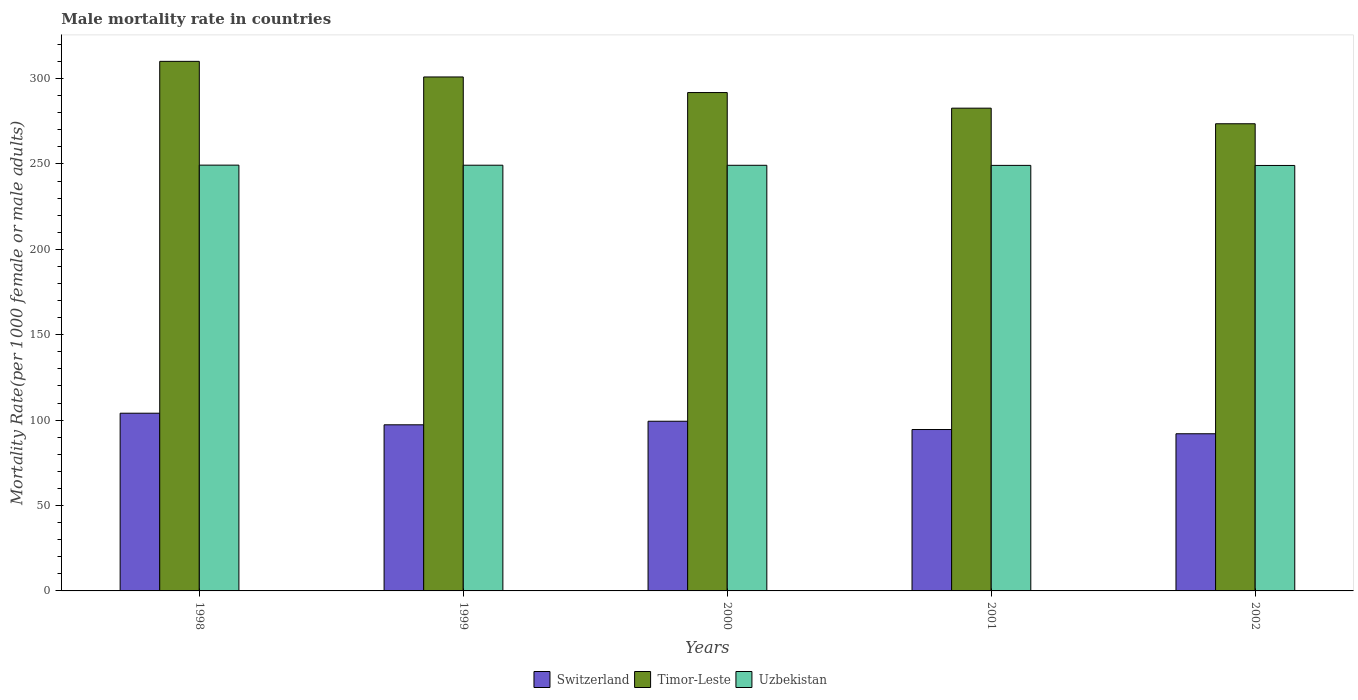How many different coloured bars are there?
Provide a short and direct response. 3. How many groups of bars are there?
Give a very brief answer. 5. How many bars are there on the 3rd tick from the left?
Your answer should be compact. 3. What is the label of the 1st group of bars from the left?
Your answer should be very brief. 1998. In how many cases, is the number of bars for a given year not equal to the number of legend labels?
Provide a succinct answer. 0. What is the male mortality rate in Switzerland in 2002?
Your response must be concise. 92.02. Across all years, what is the maximum male mortality rate in Uzbekistan?
Provide a short and direct response. 249.32. Across all years, what is the minimum male mortality rate in Uzbekistan?
Give a very brief answer. 249.12. In which year was the male mortality rate in Timor-Leste maximum?
Provide a succinct answer. 1998. What is the total male mortality rate in Uzbekistan in the graph?
Provide a short and direct response. 1246.09. What is the difference between the male mortality rate in Uzbekistan in 1999 and that in 2001?
Provide a succinct answer. 0.1. What is the difference between the male mortality rate in Timor-Leste in 2000 and the male mortality rate in Switzerland in 1998?
Give a very brief answer. 187.76. What is the average male mortality rate in Uzbekistan per year?
Provide a short and direct response. 249.22. In the year 1999, what is the difference between the male mortality rate in Switzerland and male mortality rate in Timor-Leste?
Make the answer very short. -203.68. What is the ratio of the male mortality rate in Timor-Leste in 1998 to that in 1999?
Give a very brief answer. 1.03. Is the male mortality rate in Timor-Leste in 1998 less than that in 1999?
Offer a terse response. No. What is the difference between the highest and the second highest male mortality rate in Uzbekistan?
Your response must be concise. 0.05. What is the difference between the highest and the lowest male mortality rate in Timor-Leste?
Provide a succinct answer. 36.54. In how many years, is the male mortality rate in Uzbekistan greater than the average male mortality rate in Uzbekistan taken over all years?
Provide a short and direct response. 2. Is the sum of the male mortality rate in Switzerland in 2001 and 2002 greater than the maximum male mortality rate in Timor-Leste across all years?
Your answer should be compact. No. What does the 3rd bar from the left in 2002 represents?
Provide a succinct answer. Uzbekistan. What does the 3rd bar from the right in 2000 represents?
Ensure brevity in your answer.  Switzerland. How many bars are there?
Provide a succinct answer. 15. Are all the bars in the graph horizontal?
Offer a very short reply. No. How many years are there in the graph?
Your answer should be compact. 5. What is the difference between two consecutive major ticks on the Y-axis?
Give a very brief answer. 50. Are the values on the major ticks of Y-axis written in scientific E-notation?
Offer a very short reply. No. Does the graph contain any zero values?
Provide a succinct answer. No. How many legend labels are there?
Offer a terse response. 3. How are the legend labels stacked?
Ensure brevity in your answer.  Horizontal. What is the title of the graph?
Your answer should be compact. Male mortality rate in countries. Does "Europe(all income levels)" appear as one of the legend labels in the graph?
Ensure brevity in your answer.  No. What is the label or title of the Y-axis?
Provide a succinct answer. Mortality Rate(per 1000 female or male adults). What is the Mortality Rate(per 1000 female or male adults) of Switzerland in 1998?
Provide a succinct answer. 104.05. What is the Mortality Rate(per 1000 female or male adults) in Timor-Leste in 1998?
Your answer should be very brief. 310.08. What is the Mortality Rate(per 1000 female or male adults) in Uzbekistan in 1998?
Give a very brief answer. 249.32. What is the Mortality Rate(per 1000 female or male adults) of Switzerland in 1999?
Provide a short and direct response. 97.26. What is the Mortality Rate(per 1000 female or male adults) of Timor-Leste in 1999?
Keep it short and to the point. 300.94. What is the Mortality Rate(per 1000 female or male adults) of Uzbekistan in 1999?
Ensure brevity in your answer.  249.27. What is the Mortality Rate(per 1000 female or male adults) in Switzerland in 2000?
Offer a terse response. 99.35. What is the Mortality Rate(per 1000 female or male adults) in Timor-Leste in 2000?
Give a very brief answer. 291.81. What is the Mortality Rate(per 1000 female or male adults) in Uzbekistan in 2000?
Offer a terse response. 249.22. What is the Mortality Rate(per 1000 female or male adults) in Switzerland in 2001?
Ensure brevity in your answer.  94.51. What is the Mortality Rate(per 1000 female or male adults) of Timor-Leste in 2001?
Your answer should be compact. 282.67. What is the Mortality Rate(per 1000 female or male adults) of Uzbekistan in 2001?
Your answer should be very brief. 249.17. What is the Mortality Rate(per 1000 female or male adults) in Switzerland in 2002?
Offer a very short reply. 92.02. What is the Mortality Rate(per 1000 female or male adults) of Timor-Leste in 2002?
Provide a short and direct response. 273.54. What is the Mortality Rate(per 1000 female or male adults) in Uzbekistan in 2002?
Provide a short and direct response. 249.12. Across all years, what is the maximum Mortality Rate(per 1000 female or male adults) in Switzerland?
Your answer should be compact. 104.05. Across all years, what is the maximum Mortality Rate(per 1000 female or male adults) in Timor-Leste?
Make the answer very short. 310.08. Across all years, what is the maximum Mortality Rate(per 1000 female or male adults) of Uzbekistan?
Offer a very short reply. 249.32. Across all years, what is the minimum Mortality Rate(per 1000 female or male adults) of Switzerland?
Make the answer very short. 92.02. Across all years, what is the minimum Mortality Rate(per 1000 female or male adults) of Timor-Leste?
Your answer should be very brief. 273.54. Across all years, what is the minimum Mortality Rate(per 1000 female or male adults) of Uzbekistan?
Your answer should be compact. 249.12. What is the total Mortality Rate(per 1000 female or male adults) in Switzerland in the graph?
Give a very brief answer. 487.19. What is the total Mortality Rate(per 1000 female or male adults) in Timor-Leste in the graph?
Offer a terse response. 1459.04. What is the total Mortality Rate(per 1000 female or male adults) in Uzbekistan in the graph?
Your response must be concise. 1246.09. What is the difference between the Mortality Rate(per 1000 female or male adults) of Switzerland in 1998 and that in 1999?
Provide a succinct answer. 6.79. What is the difference between the Mortality Rate(per 1000 female or male adults) of Timor-Leste in 1998 and that in 1999?
Ensure brevity in your answer.  9.14. What is the difference between the Mortality Rate(per 1000 female or male adults) in Uzbekistan in 1998 and that in 1999?
Ensure brevity in your answer.  0.05. What is the difference between the Mortality Rate(per 1000 female or male adults) in Switzerland in 1998 and that in 2000?
Offer a very short reply. 4.7. What is the difference between the Mortality Rate(per 1000 female or male adults) in Timor-Leste in 1998 and that in 2000?
Provide a succinct answer. 18.27. What is the difference between the Mortality Rate(per 1000 female or male adults) in Uzbekistan in 1998 and that in 2000?
Your answer should be very brief. 0.1. What is the difference between the Mortality Rate(per 1000 female or male adults) in Switzerland in 1998 and that in 2001?
Your answer should be compact. 9.54. What is the difference between the Mortality Rate(per 1000 female or male adults) of Timor-Leste in 1998 and that in 2001?
Give a very brief answer. 27.41. What is the difference between the Mortality Rate(per 1000 female or male adults) of Uzbekistan in 1998 and that in 2001?
Provide a short and direct response. 0.15. What is the difference between the Mortality Rate(per 1000 female or male adults) of Switzerland in 1998 and that in 2002?
Give a very brief answer. 12.03. What is the difference between the Mortality Rate(per 1000 female or male adults) of Timor-Leste in 1998 and that in 2002?
Offer a very short reply. 36.54. What is the difference between the Mortality Rate(per 1000 female or male adults) of Uzbekistan in 1998 and that in 2002?
Your response must be concise. 0.2. What is the difference between the Mortality Rate(per 1000 female or male adults) in Switzerland in 1999 and that in 2000?
Make the answer very short. -2.09. What is the difference between the Mortality Rate(per 1000 female or male adults) in Timor-Leste in 1999 and that in 2000?
Your answer should be compact. 9.14. What is the difference between the Mortality Rate(per 1000 female or male adults) in Uzbekistan in 1999 and that in 2000?
Your answer should be very brief. 0.05. What is the difference between the Mortality Rate(per 1000 female or male adults) in Switzerland in 1999 and that in 2001?
Offer a very short reply. 2.75. What is the difference between the Mortality Rate(per 1000 female or male adults) of Timor-Leste in 1999 and that in 2001?
Provide a short and direct response. 18.27. What is the difference between the Mortality Rate(per 1000 female or male adults) of Uzbekistan in 1999 and that in 2001?
Offer a terse response. 0.1. What is the difference between the Mortality Rate(per 1000 female or male adults) of Switzerland in 1999 and that in 2002?
Your answer should be compact. 5.24. What is the difference between the Mortality Rate(per 1000 female or male adults) of Timor-Leste in 1999 and that in 2002?
Your answer should be very brief. 27.41. What is the difference between the Mortality Rate(per 1000 female or male adults) of Uzbekistan in 1999 and that in 2002?
Offer a terse response. 0.15. What is the difference between the Mortality Rate(per 1000 female or male adults) in Switzerland in 2000 and that in 2001?
Offer a very short reply. 4.84. What is the difference between the Mortality Rate(per 1000 female or male adults) of Timor-Leste in 2000 and that in 2001?
Your answer should be very brief. 9.14. What is the difference between the Mortality Rate(per 1000 female or male adults) in Uzbekistan in 2000 and that in 2001?
Ensure brevity in your answer.  0.05. What is the difference between the Mortality Rate(per 1000 female or male adults) in Switzerland in 2000 and that in 2002?
Your response must be concise. 7.33. What is the difference between the Mortality Rate(per 1000 female or male adults) of Timor-Leste in 2000 and that in 2002?
Make the answer very short. 18.27. What is the difference between the Mortality Rate(per 1000 female or male adults) in Uzbekistan in 2000 and that in 2002?
Make the answer very short. 0.1. What is the difference between the Mortality Rate(per 1000 female or male adults) of Switzerland in 2001 and that in 2002?
Your answer should be compact. 2.48. What is the difference between the Mortality Rate(per 1000 female or male adults) in Timor-Leste in 2001 and that in 2002?
Ensure brevity in your answer.  9.14. What is the difference between the Mortality Rate(per 1000 female or male adults) in Uzbekistan in 2001 and that in 2002?
Ensure brevity in your answer.  0.05. What is the difference between the Mortality Rate(per 1000 female or male adults) in Switzerland in 1998 and the Mortality Rate(per 1000 female or male adults) in Timor-Leste in 1999?
Offer a very short reply. -196.89. What is the difference between the Mortality Rate(per 1000 female or male adults) of Switzerland in 1998 and the Mortality Rate(per 1000 female or male adults) of Uzbekistan in 1999?
Keep it short and to the point. -145.22. What is the difference between the Mortality Rate(per 1000 female or male adults) of Timor-Leste in 1998 and the Mortality Rate(per 1000 female or male adults) of Uzbekistan in 1999?
Your answer should be very brief. 60.81. What is the difference between the Mortality Rate(per 1000 female or male adults) of Switzerland in 1998 and the Mortality Rate(per 1000 female or male adults) of Timor-Leste in 2000?
Provide a succinct answer. -187.76. What is the difference between the Mortality Rate(per 1000 female or male adults) in Switzerland in 1998 and the Mortality Rate(per 1000 female or male adults) in Uzbekistan in 2000?
Give a very brief answer. -145.17. What is the difference between the Mortality Rate(per 1000 female or male adults) of Timor-Leste in 1998 and the Mortality Rate(per 1000 female or male adults) of Uzbekistan in 2000?
Offer a terse response. 60.86. What is the difference between the Mortality Rate(per 1000 female or male adults) in Switzerland in 1998 and the Mortality Rate(per 1000 female or male adults) in Timor-Leste in 2001?
Offer a very short reply. -178.62. What is the difference between the Mortality Rate(per 1000 female or male adults) in Switzerland in 1998 and the Mortality Rate(per 1000 female or male adults) in Uzbekistan in 2001?
Offer a terse response. -145.12. What is the difference between the Mortality Rate(per 1000 female or male adults) in Timor-Leste in 1998 and the Mortality Rate(per 1000 female or male adults) in Uzbekistan in 2001?
Ensure brevity in your answer.  60.91. What is the difference between the Mortality Rate(per 1000 female or male adults) of Switzerland in 1998 and the Mortality Rate(per 1000 female or male adults) of Timor-Leste in 2002?
Make the answer very short. -169.49. What is the difference between the Mortality Rate(per 1000 female or male adults) of Switzerland in 1998 and the Mortality Rate(per 1000 female or male adults) of Uzbekistan in 2002?
Offer a very short reply. -145.07. What is the difference between the Mortality Rate(per 1000 female or male adults) in Timor-Leste in 1998 and the Mortality Rate(per 1000 female or male adults) in Uzbekistan in 2002?
Your answer should be very brief. 60.96. What is the difference between the Mortality Rate(per 1000 female or male adults) of Switzerland in 1999 and the Mortality Rate(per 1000 female or male adults) of Timor-Leste in 2000?
Ensure brevity in your answer.  -194.55. What is the difference between the Mortality Rate(per 1000 female or male adults) of Switzerland in 1999 and the Mortality Rate(per 1000 female or male adults) of Uzbekistan in 2000?
Your answer should be compact. -151.95. What is the difference between the Mortality Rate(per 1000 female or male adults) of Timor-Leste in 1999 and the Mortality Rate(per 1000 female or male adults) of Uzbekistan in 2000?
Offer a terse response. 51.73. What is the difference between the Mortality Rate(per 1000 female or male adults) of Switzerland in 1999 and the Mortality Rate(per 1000 female or male adults) of Timor-Leste in 2001?
Your answer should be compact. -185.41. What is the difference between the Mortality Rate(per 1000 female or male adults) in Switzerland in 1999 and the Mortality Rate(per 1000 female or male adults) in Uzbekistan in 2001?
Ensure brevity in your answer.  -151.91. What is the difference between the Mortality Rate(per 1000 female or male adults) in Timor-Leste in 1999 and the Mortality Rate(per 1000 female or male adults) in Uzbekistan in 2001?
Your answer should be compact. 51.78. What is the difference between the Mortality Rate(per 1000 female or male adults) in Switzerland in 1999 and the Mortality Rate(per 1000 female or male adults) in Timor-Leste in 2002?
Offer a very short reply. -176.27. What is the difference between the Mortality Rate(per 1000 female or male adults) in Switzerland in 1999 and the Mortality Rate(per 1000 female or male adults) in Uzbekistan in 2002?
Your answer should be compact. -151.86. What is the difference between the Mortality Rate(per 1000 female or male adults) in Timor-Leste in 1999 and the Mortality Rate(per 1000 female or male adults) in Uzbekistan in 2002?
Your answer should be compact. 51.82. What is the difference between the Mortality Rate(per 1000 female or male adults) in Switzerland in 2000 and the Mortality Rate(per 1000 female or male adults) in Timor-Leste in 2001?
Offer a very short reply. -183.32. What is the difference between the Mortality Rate(per 1000 female or male adults) in Switzerland in 2000 and the Mortality Rate(per 1000 female or male adults) in Uzbekistan in 2001?
Your answer should be compact. -149.82. What is the difference between the Mortality Rate(per 1000 female or male adults) in Timor-Leste in 2000 and the Mortality Rate(per 1000 female or male adults) in Uzbekistan in 2001?
Keep it short and to the point. 42.64. What is the difference between the Mortality Rate(per 1000 female or male adults) of Switzerland in 2000 and the Mortality Rate(per 1000 female or male adults) of Timor-Leste in 2002?
Give a very brief answer. -174.19. What is the difference between the Mortality Rate(per 1000 female or male adults) of Switzerland in 2000 and the Mortality Rate(per 1000 female or male adults) of Uzbekistan in 2002?
Your response must be concise. -149.77. What is the difference between the Mortality Rate(per 1000 female or male adults) of Timor-Leste in 2000 and the Mortality Rate(per 1000 female or male adults) of Uzbekistan in 2002?
Your answer should be very brief. 42.69. What is the difference between the Mortality Rate(per 1000 female or male adults) of Switzerland in 2001 and the Mortality Rate(per 1000 female or male adults) of Timor-Leste in 2002?
Keep it short and to the point. -179.03. What is the difference between the Mortality Rate(per 1000 female or male adults) of Switzerland in 2001 and the Mortality Rate(per 1000 female or male adults) of Uzbekistan in 2002?
Offer a terse response. -154.61. What is the difference between the Mortality Rate(per 1000 female or male adults) in Timor-Leste in 2001 and the Mortality Rate(per 1000 female or male adults) in Uzbekistan in 2002?
Keep it short and to the point. 33.55. What is the average Mortality Rate(per 1000 female or male adults) in Switzerland per year?
Give a very brief answer. 97.44. What is the average Mortality Rate(per 1000 female or male adults) of Timor-Leste per year?
Offer a very short reply. 291.81. What is the average Mortality Rate(per 1000 female or male adults) of Uzbekistan per year?
Make the answer very short. 249.22. In the year 1998, what is the difference between the Mortality Rate(per 1000 female or male adults) in Switzerland and Mortality Rate(per 1000 female or male adults) in Timor-Leste?
Provide a succinct answer. -206.03. In the year 1998, what is the difference between the Mortality Rate(per 1000 female or male adults) in Switzerland and Mortality Rate(per 1000 female or male adults) in Uzbekistan?
Provide a short and direct response. -145.26. In the year 1998, what is the difference between the Mortality Rate(per 1000 female or male adults) of Timor-Leste and Mortality Rate(per 1000 female or male adults) of Uzbekistan?
Your answer should be compact. 60.76. In the year 1999, what is the difference between the Mortality Rate(per 1000 female or male adults) of Switzerland and Mortality Rate(per 1000 female or male adults) of Timor-Leste?
Give a very brief answer. -203.68. In the year 1999, what is the difference between the Mortality Rate(per 1000 female or male adults) in Switzerland and Mortality Rate(per 1000 female or male adults) in Uzbekistan?
Offer a very short reply. -152. In the year 1999, what is the difference between the Mortality Rate(per 1000 female or male adults) in Timor-Leste and Mortality Rate(per 1000 female or male adults) in Uzbekistan?
Offer a terse response. 51.68. In the year 2000, what is the difference between the Mortality Rate(per 1000 female or male adults) in Switzerland and Mortality Rate(per 1000 female or male adults) in Timor-Leste?
Offer a very short reply. -192.46. In the year 2000, what is the difference between the Mortality Rate(per 1000 female or male adults) in Switzerland and Mortality Rate(per 1000 female or male adults) in Uzbekistan?
Make the answer very short. -149.87. In the year 2000, what is the difference between the Mortality Rate(per 1000 female or male adults) of Timor-Leste and Mortality Rate(per 1000 female or male adults) of Uzbekistan?
Your answer should be very brief. 42.59. In the year 2001, what is the difference between the Mortality Rate(per 1000 female or male adults) of Switzerland and Mortality Rate(per 1000 female or male adults) of Timor-Leste?
Your answer should be very brief. -188.16. In the year 2001, what is the difference between the Mortality Rate(per 1000 female or male adults) of Switzerland and Mortality Rate(per 1000 female or male adults) of Uzbekistan?
Offer a terse response. -154.66. In the year 2001, what is the difference between the Mortality Rate(per 1000 female or male adults) in Timor-Leste and Mortality Rate(per 1000 female or male adults) in Uzbekistan?
Your answer should be compact. 33.5. In the year 2002, what is the difference between the Mortality Rate(per 1000 female or male adults) in Switzerland and Mortality Rate(per 1000 female or male adults) in Timor-Leste?
Give a very brief answer. -181.51. In the year 2002, what is the difference between the Mortality Rate(per 1000 female or male adults) in Switzerland and Mortality Rate(per 1000 female or male adults) in Uzbekistan?
Provide a short and direct response. -157.09. In the year 2002, what is the difference between the Mortality Rate(per 1000 female or male adults) of Timor-Leste and Mortality Rate(per 1000 female or male adults) of Uzbekistan?
Your response must be concise. 24.42. What is the ratio of the Mortality Rate(per 1000 female or male adults) in Switzerland in 1998 to that in 1999?
Your answer should be compact. 1.07. What is the ratio of the Mortality Rate(per 1000 female or male adults) in Timor-Leste in 1998 to that in 1999?
Offer a very short reply. 1.03. What is the ratio of the Mortality Rate(per 1000 female or male adults) in Switzerland in 1998 to that in 2000?
Your response must be concise. 1.05. What is the ratio of the Mortality Rate(per 1000 female or male adults) of Timor-Leste in 1998 to that in 2000?
Your answer should be very brief. 1.06. What is the ratio of the Mortality Rate(per 1000 female or male adults) in Switzerland in 1998 to that in 2001?
Provide a short and direct response. 1.1. What is the ratio of the Mortality Rate(per 1000 female or male adults) of Timor-Leste in 1998 to that in 2001?
Make the answer very short. 1.1. What is the ratio of the Mortality Rate(per 1000 female or male adults) in Uzbekistan in 1998 to that in 2001?
Offer a terse response. 1. What is the ratio of the Mortality Rate(per 1000 female or male adults) in Switzerland in 1998 to that in 2002?
Provide a short and direct response. 1.13. What is the ratio of the Mortality Rate(per 1000 female or male adults) in Timor-Leste in 1998 to that in 2002?
Provide a short and direct response. 1.13. What is the ratio of the Mortality Rate(per 1000 female or male adults) of Uzbekistan in 1998 to that in 2002?
Give a very brief answer. 1. What is the ratio of the Mortality Rate(per 1000 female or male adults) of Timor-Leste in 1999 to that in 2000?
Your answer should be very brief. 1.03. What is the ratio of the Mortality Rate(per 1000 female or male adults) in Switzerland in 1999 to that in 2001?
Keep it short and to the point. 1.03. What is the ratio of the Mortality Rate(per 1000 female or male adults) in Timor-Leste in 1999 to that in 2001?
Your answer should be compact. 1.06. What is the ratio of the Mortality Rate(per 1000 female or male adults) of Switzerland in 1999 to that in 2002?
Provide a short and direct response. 1.06. What is the ratio of the Mortality Rate(per 1000 female or male adults) in Timor-Leste in 1999 to that in 2002?
Ensure brevity in your answer.  1.1. What is the ratio of the Mortality Rate(per 1000 female or male adults) in Uzbekistan in 1999 to that in 2002?
Give a very brief answer. 1. What is the ratio of the Mortality Rate(per 1000 female or male adults) in Switzerland in 2000 to that in 2001?
Keep it short and to the point. 1.05. What is the ratio of the Mortality Rate(per 1000 female or male adults) in Timor-Leste in 2000 to that in 2001?
Your answer should be compact. 1.03. What is the ratio of the Mortality Rate(per 1000 female or male adults) of Uzbekistan in 2000 to that in 2001?
Make the answer very short. 1. What is the ratio of the Mortality Rate(per 1000 female or male adults) in Switzerland in 2000 to that in 2002?
Offer a terse response. 1.08. What is the ratio of the Mortality Rate(per 1000 female or male adults) of Timor-Leste in 2000 to that in 2002?
Give a very brief answer. 1.07. What is the ratio of the Mortality Rate(per 1000 female or male adults) in Uzbekistan in 2000 to that in 2002?
Make the answer very short. 1. What is the ratio of the Mortality Rate(per 1000 female or male adults) of Switzerland in 2001 to that in 2002?
Offer a very short reply. 1.03. What is the ratio of the Mortality Rate(per 1000 female or male adults) of Timor-Leste in 2001 to that in 2002?
Offer a terse response. 1.03. What is the difference between the highest and the second highest Mortality Rate(per 1000 female or male adults) of Switzerland?
Ensure brevity in your answer.  4.7. What is the difference between the highest and the second highest Mortality Rate(per 1000 female or male adults) in Timor-Leste?
Your answer should be compact. 9.14. What is the difference between the highest and the second highest Mortality Rate(per 1000 female or male adults) of Uzbekistan?
Offer a very short reply. 0.05. What is the difference between the highest and the lowest Mortality Rate(per 1000 female or male adults) of Switzerland?
Keep it short and to the point. 12.03. What is the difference between the highest and the lowest Mortality Rate(per 1000 female or male adults) in Timor-Leste?
Offer a terse response. 36.54. What is the difference between the highest and the lowest Mortality Rate(per 1000 female or male adults) in Uzbekistan?
Keep it short and to the point. 0.2. 